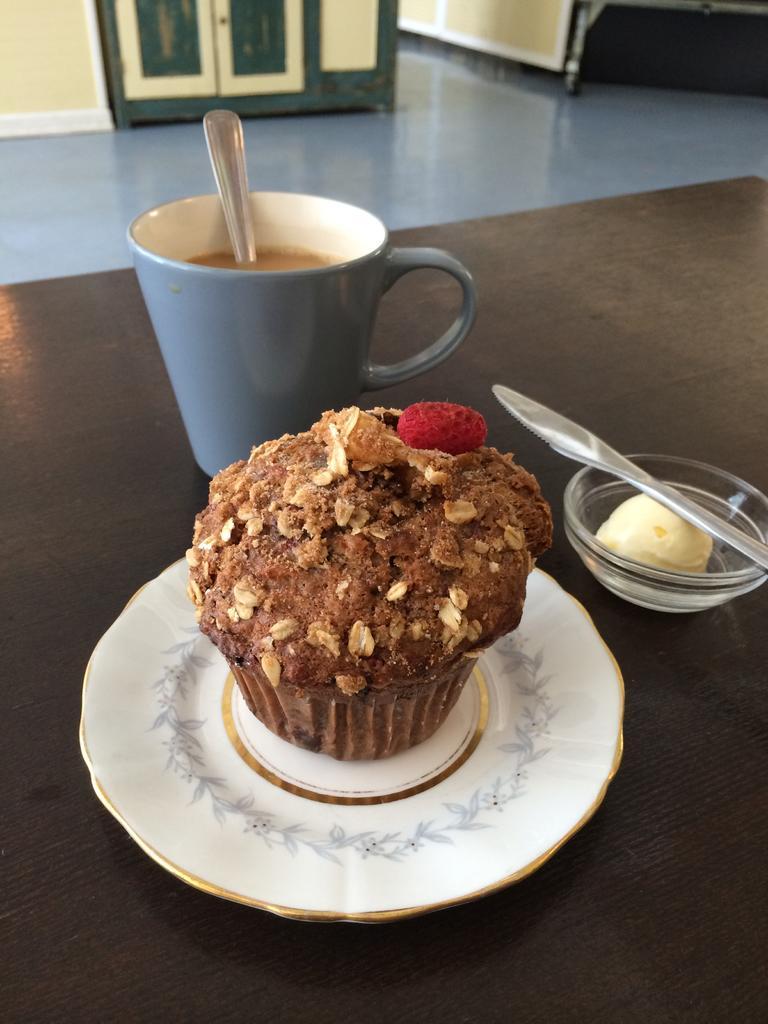How would you summarize this image in a sentence or two? At the bottom of the image there is a wooden floor. In the middle of the image there is a white plate with muffin on it. Beside the plate there is a bowl with cream and spoon on it. Behind the plate there is a grey color cup with spoon and liquid in it. In the background there is a grey floor and there is a wall with door. 